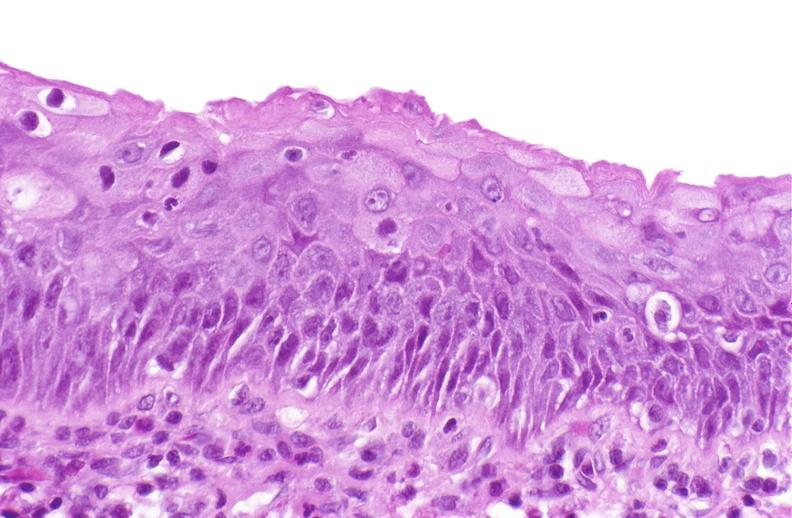where is this?
Answer the question using a single word or phrase. Urinary 